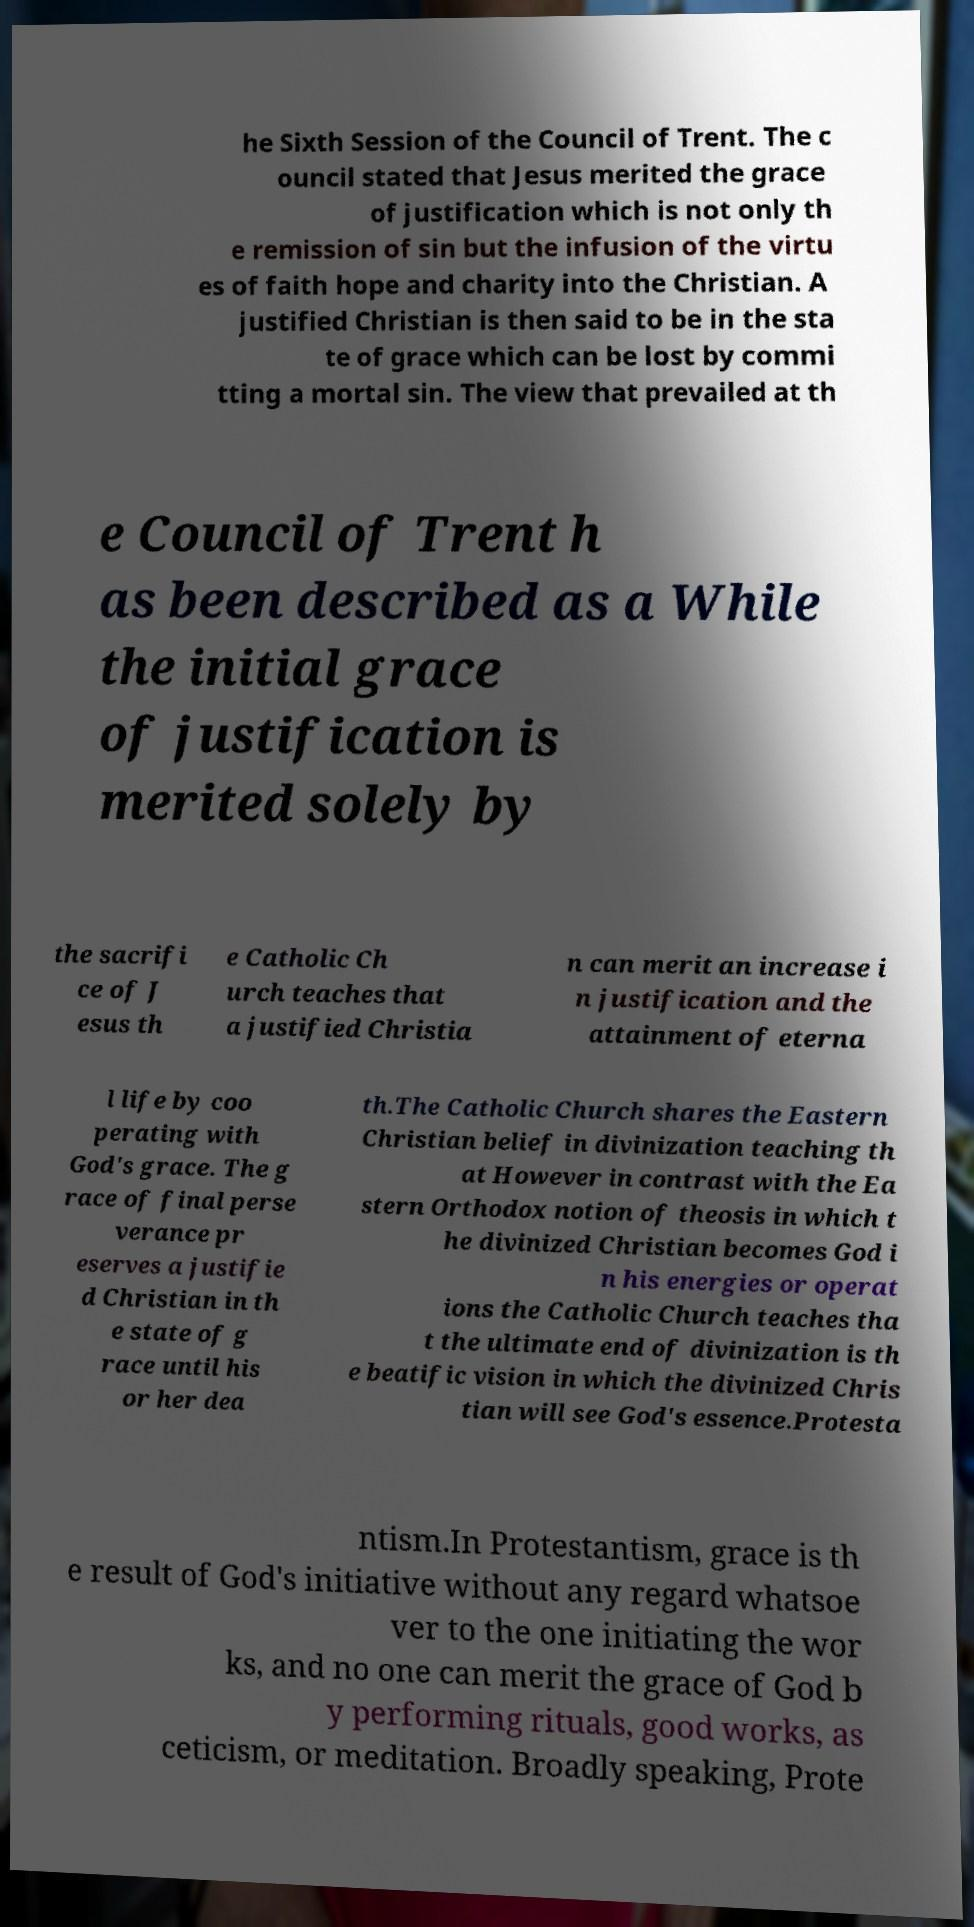Could you extract and type out the text from this image? he Sixth Session of the Council of Trent. The c ouncil stated that Jesus merited the grace of justification which is not only th e remission of sin but the infusion of the virtu es of faith hope and charity into the Christian. A justified Christian is then said to be in the sta te of grace which can be lost by commi tting a mortal sin. The view that prevailed at th e Council of Trent h as been described as a While the initial grace of justification is merited solely by the sacrifi ce of J esus th e Catholic Ch urch teaches that a justified Christia n can merit an increase i n justification and the attainment of eterna l life by coo perating with God's grace. The g race of final perse verance pr eserves a justifie d Christian in th e state of g race until his or her dea th.The Catholic Church shares the Eastern Christian belief in divinization teaching th at However in contrast with the Ea stern Orthodox notion of theosis in which t he divinized Christian becomes God i n his energies or operat ions the Catholic Church teaches tha t the ultimate end of divinization is th e beatific vision in which the divinized Chris tian will see God's essence.Protesta ntism.In Protestantism, grace is th e result of God's initiative without any regard whatsoe ver to the one initiating the wor ks, and no one can merit the grace of God b y performing rituals, good works, as ceticism, or meditation. Broadly speaking, Prote 